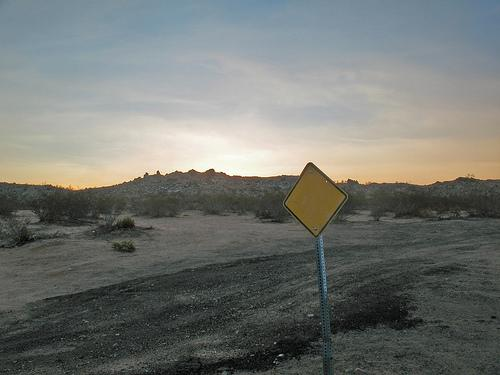Question: what time is it?
Choices:
A. Twilight.
B. Dusk.
C. Evening.
D. Sunset.
Answer with the letter. Answer: B 